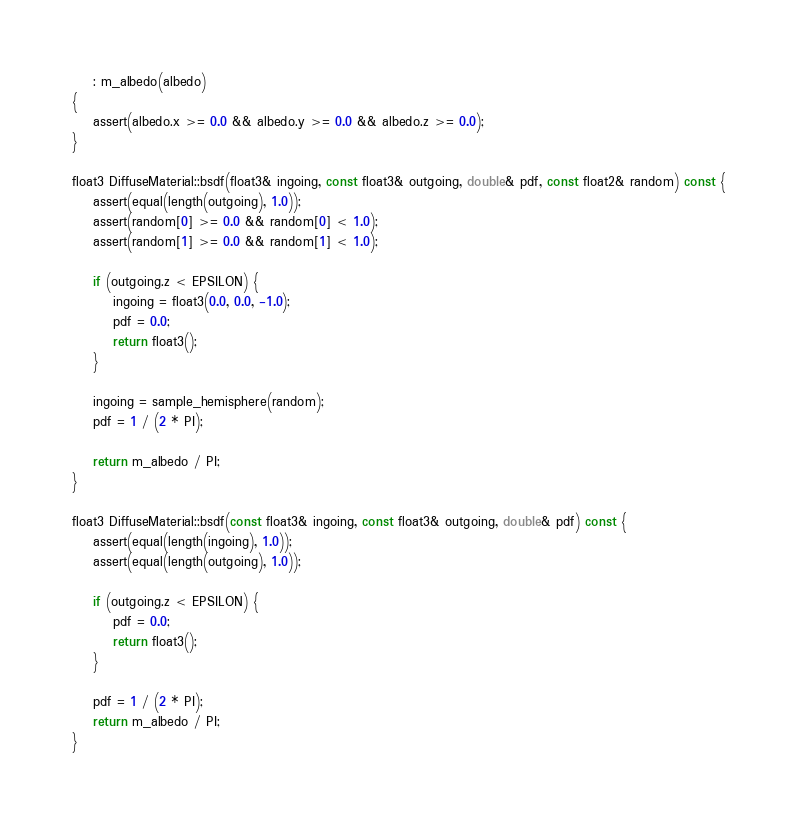Convert code to text. <code><loc_0><loc_0><loc_500><loc_500><_C++_>    : m_albedo(albedo)
{
    assert(albedo.x >= 0.0 && albedo.y >= 0.0 && albedo.z >= 0.0);
}

float3 DiffuseMaterial::bsdf(float3& ingoing, const float3& outgoing, double& pdf, const float2& random) const {
    assert(equal(length(outgoing), 1.0));
    assert(random[0] >= 0.0 && random[0] < 1.0);
    assert(random[1] >= 0.0 && random[1] < 1.0);

    if (outgoing.z < EPSILON) {
        ingoing = float3(0.0, 0.0, -1.0);
        pdf = 0.0;
        return float3();
    }

    ingoing = sample_hemisphere(random);
    pdf = 1 / (2 * PI);

    return m_albedo / PI;
}

float3 DiffuseMaterial::bsdf(const float3& ingoing, const float3& outgoing, double& pdf) const {
    assert(equal(length(ingoing), 1.0));
    assert(equal(length(outgoing), 1.0));

    if (outgoing.z < EPSILON) {
        pdf = 0.0;
        return float3();
    }

    pdf = 1 / (2 * PI);
    return m_albedo / PI;
}
</code> 